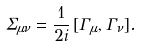<formula> <loc_0><loc_0><loc_500><loc_500>\Sigma _ { \mu \nu } = \frac { 1 } { 2 i } \, [ \Gamma _ { \mu } , \Gamma _ { \nu } ] .</formula> 